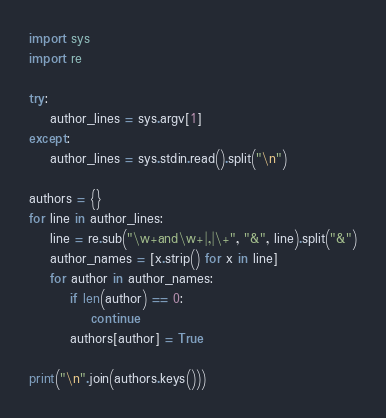Convert code to text. <code><loc_0><loc_0><loc_500><loc_500><_Python_>
import sys
import re

try:
    author_lines = sys.argv[1]
except:
    author_lines = sys.stdin.read().split("\n")

authors = {}
for line in author_lines:
    line = re.sub("\w+and\w+|,|\+", "&", line).split("&")
    author_names = [x.strip() for x in line]
    for author in author_names:
        if len(author) == 0:
            continue
        authors[author] = True

print("\n".join(authors.keys()))
</code> 